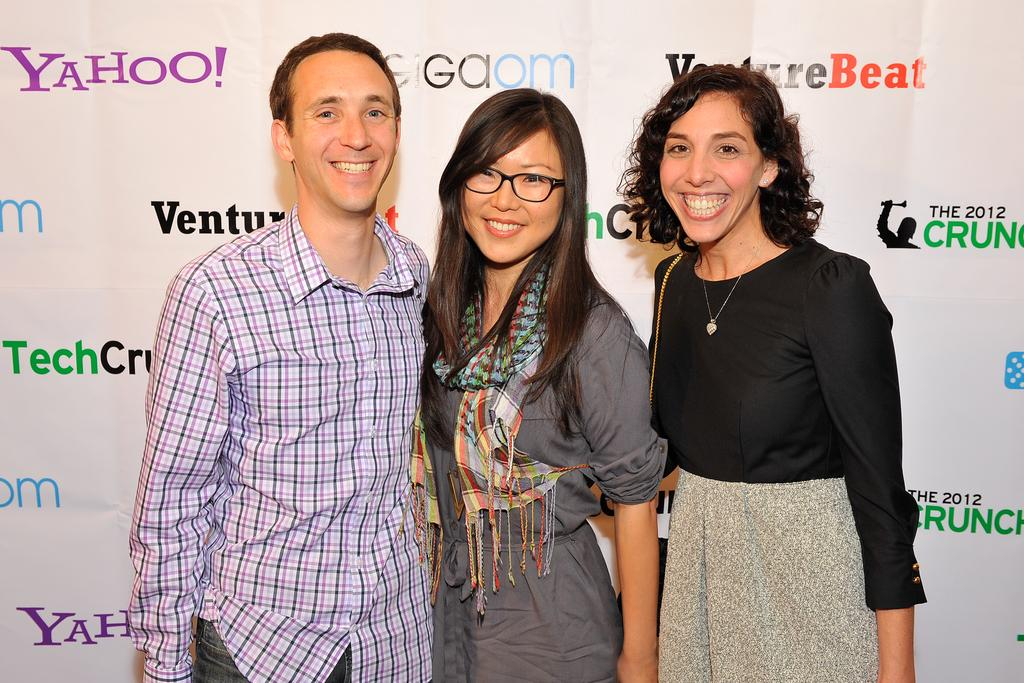How many people are in the image? There are three people in the image. What are the people doing in the image? The people are standing on the floor and smiling. What can be seen behind the people in the image? There is a banner visible behind the people. What type of punishment is being given to the uncle in the image? There is no uncle or punishment present in the image. What songs are the people singing in the image? There is no indication in the image that the people are singing any songs. 